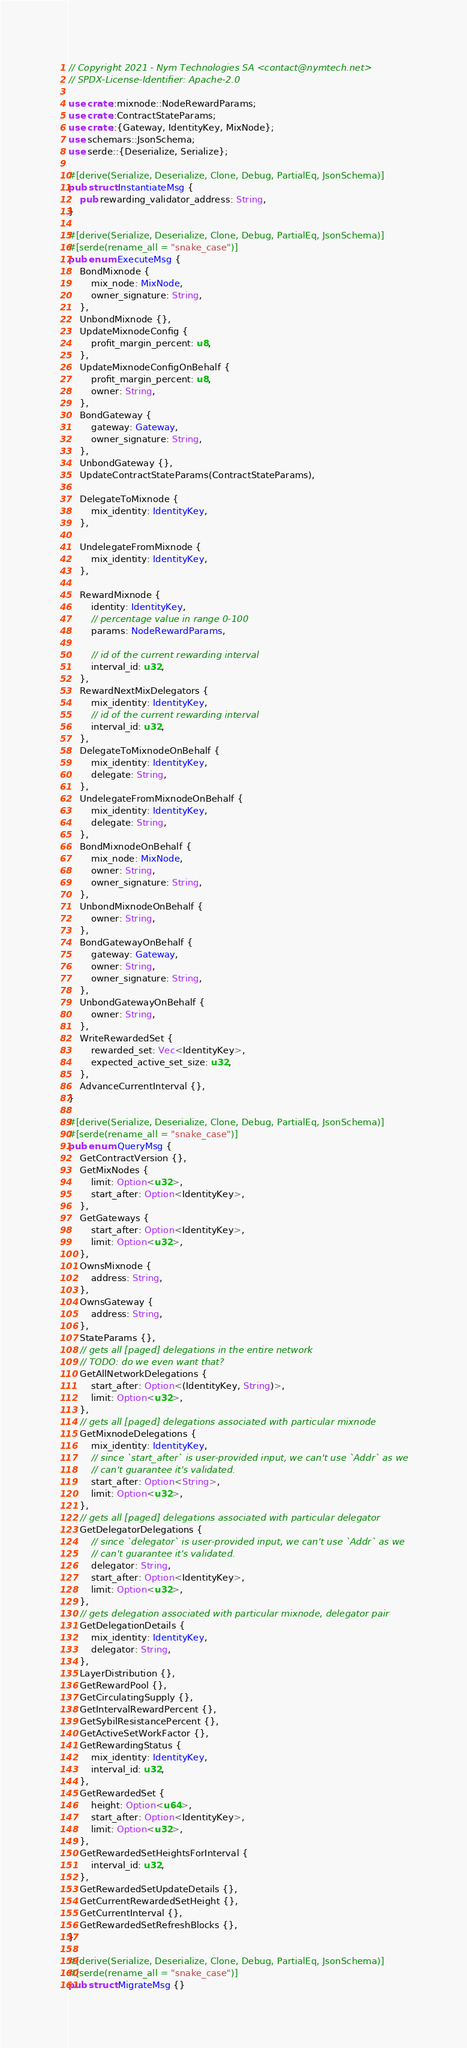<code> <loc_0><loc_0><loc_500><loc_500><_Rust_>// Copyright 2021 - Nym Technologies SA <contact@nymtech.net>
// SPDX-License-Identifier: Apache-2.0

use crate::mixnode::NodeRewardParams;
use crate::ContractStateParams;
use crate::{Gateway, IdentityKey, MixNode};
use schemars::JsonSchema;
use serde::{Deserialize, Serialize};

#[derive(Serialize, Deserialize, Clone, Debug, PartialEq, JsonSchema)]
pub struct InstantiateMsg {
    pub rewarding_validator_address: String,
}

#[derive(Serialize, Deserialize, Clone, Debug, PartialEq, JsonSchema)]
#[serde(rename_all = "snake_case")]
pub enum ExecuteMsg {
    BondMixnode {
        mix_node: MixNode,
        owner_signature: String,
    },
    UnbondMixnode {},
    UpdateMixnodeConfig {
        profit_margin_percent: u8,
    },
    UpdateMixnodeConfigOnBehalf {
        profit_margin_percent: u8,
        owner: String,
    },
    BondGateway {
        gateway: Gateway,
        owner_signature: String,
    },
    UnbondGateway {},
    UpdateContractStateParams(ContractStateParams),

    DelegateToMixnode {
        mix_identity: IdentityKey,
    },

    UndelegateFromMixnode {
        mix_identity: IdentityKey,
    },

    RewardMixnode {
        identity: IdentityKey,
        // percentage value in range 0-100
        params: NodeRewardParams,

        // id of the current rewarding interval
        interval_id: u32,
    },
    RewardNextMixDelegators {
        mix_identity: IdentityKey,
        // id of the current rewarding interval
        interval_id: u32,
    },
    DelegateToMixnodeOnBehalf {
        mix_identity: IdentityKey,
        delegate: String,
    },
    UndelegateFromMixnodeOnBehalf {
        mix_identity: IdentityKey,
        delegate: String,
    },
    BondMixnodeOnBehalf {
        mix_node: MixNode,
        owner: String,
        owner_signature: String,
    },
    UnbondMixnodeOnBehalf {
        owner: String,
    },
    BondGatewayOnBehalf {
        gateway: Gateway,
        owner: String,
        owner_signature: String,
    },
    UnbondGatewayOnBehalf {
        owner: String,
    },
    WriteRewardedSet {
        rewarded_set: Vec<IdentityKey>,
        expected_active_set_size: u32,
    },
    AdvanceCurrentInterval {},
}

#[derive(Serialize, Deserialize, Clone, Debug, PartialEq, JsonSchema)]
#[serde(rename_all = "snake_case")]
pub enum QueryMsg {
    GetContractVersion {},
    GetMixNodes {
        limit: Option<u32>,
        start_after: Option<IdentityKey>,
    },
    GetGateways {
        start_after: Option<IdentityKey>,
        limit: Option<u32>,
    },
    OwnsMixnode {
        address: String,
    },
    OwnsGateway {
        address: String,
    },
    StateParams {},
    // gets all [paged] delegations in the entire network
    // TODO: do we even want that?
    GetAllNetworkDelegations {
        start_after: Option<(IdentityKey, String)>,
        limit: Option<u32>,
    },
    // gets all [paged] delegations associated with particular mixnode
    GetMixnodeDelegations {
        mix_identity: IdentityKey,
        // since `start_after` is user-provided input, we can't use `Addr` as we
        // can't guarantee it's validated.
        start_after: Option<String>,
        limit: Option<u32>,
    },
    // gets all [paged] delegations associated with particular delegator
    GetDelegatorDelegations {
        // since `delegator` is user-provided input, we can't use `Addr` as we
        // can't guarantee it's validated.
        delegator: String,
        start_after: Option<IdentityKey>,
        limit: Option<u32>,
    },
    // gets delegation associated with particular mixnode, delegator pair
    GetDelegationDetails {
        mix_identity: IdentityKey,
        delegator: String,
    },
    LayerDistribution {},
    GetRewardPool {},
    GetCirculatingSupply {},
    GetIntervalRewardPercent {},
    GetSybilResistancePercent {},
    GetActiveSetWorkFactor {},
    GetRewardingStatus {
        mix_identity: IdentityKey,
        interval_id: u32,
    },
    GetRewardedSet {
        height: Option<u64>,
        start_after: Option<IdentityKey>,
        limit: Option<u32>,
    },
    GetRewardedSetHeightsForInterval {
        interval_id: u32,
    },
    GetRewardedSetUpdateDetails {},
    GetCurrentRewardedSetHeight {},
    GetCurrentInterval {},
    GetRewardedSetRefreshBlocks {},
}

#[derive(Serialize, Deserialize, Clone, Debug, PartialEq, JsonSchema)]
#[serde(rename_all = "snake_case")]
pub struct MigrateMsg {}
</code> 